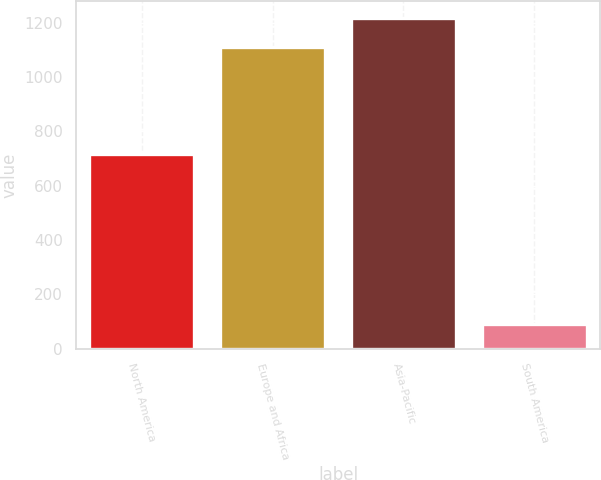Convert chart to OTSL. <chart><loc_0><loc_0><loc_500><loc_500><bar_chart><fcel>North America<fcel>Europe and Africa<fcel>Asia-Pacific<fcel>South America<nl><fcel>717<fcel>1110<fcel>1217.6<fcel>90<nl></chart> 